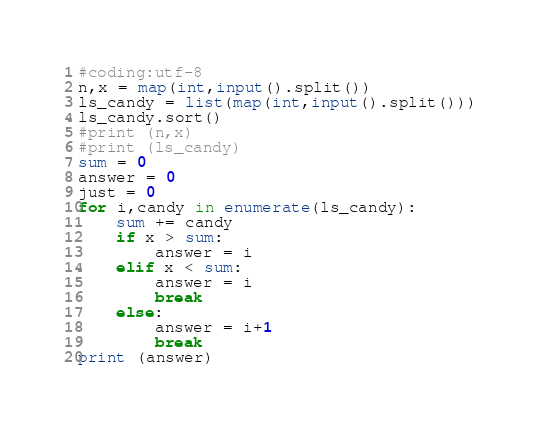Convert code to text. <code><loc_0><loc_0><loc_500><loc_500><_Python_>#coding:utf-8
n,x = map(int,input().split())
ls_candy = list(map(int,input().split()))
ls_candy.sort()
#print (n,x)
#print (ls_candy)
sum = 0
answer = 0
just = 0
for i,candy in enumerate(ls_candy):
    sum += candy
    if x > sum:
        answer = i
    elif x < sum:
        answer = i
        break
    else:
        answer = i+1
        break
print (answer)
</code> 